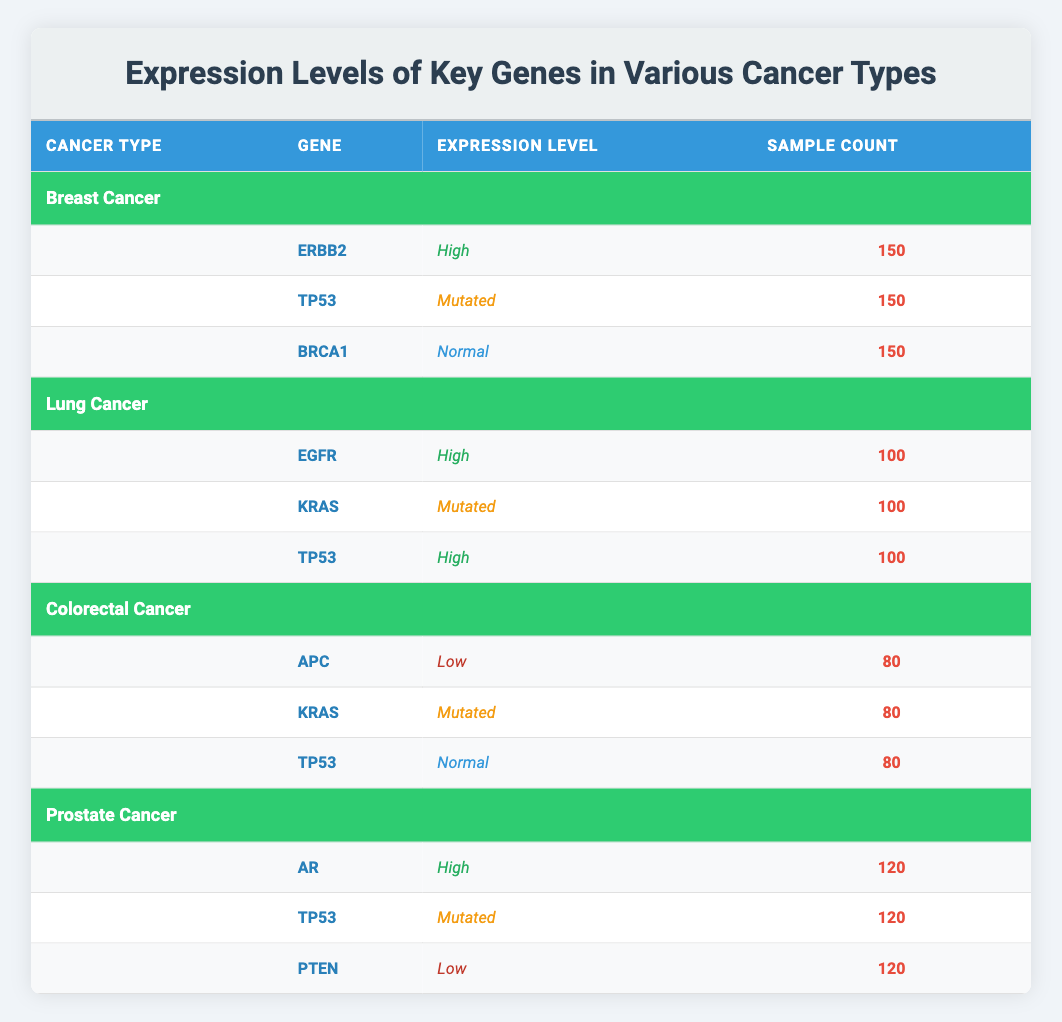What cancer type has the highest number of key genes expressed as "High"? From the table, both Breast Cancer and Lung Cancer have key genes expressed as "High." Breast Cancer has 1 (ERBB2), and Lung Cancer has 2 (EGFR and TP53). Thus, Lung Cancer has the highest number of key genes expressed as "High."
Answer: Lung Cancer Is the gene TP53 expressed as "Normal" in any type of cancer? From the table, TP53 is expressed as "Normal" in Colorectal Cancer only. For Breast and Lung cancers, it is "Mutated," and for Prostate Cancer, it is also "Mutated." Therefore, TP53 is "Normal" only in Colorectal Cancer.
Answer: Yes Which cancer type has the lowest sample count for a key gene? The sample count for key genes in Colorectal Cancer is 80 for all its genes (APC, KRAS, TP53). In comparison, other cancer types have at least one gene with a higher sample count (150 for Breast Cancer and 100 for Lung Cancer and Prostate Cancer). Thus, Colorectal Cancer has the lowest sample count for key genes.
Answer: Colorectal Cancer What is the total sample count for all key genes across all cancer types? By adding sample counts for each cancer type: Breast Cancer (150) + Lung Cancer (100) + Colorectal Cancer (80) + Prostate Cancer (120) = 150 + 100 + 80 + 120 = 450. Therefore, the total sample count is 450.
Answer: 450 Is there any cancer type where all its key genes are expressed as "Normal"? Analyzing the table shows that none of the cancer types has all key genes expressed as "Normal." For instance, Breast Cancer has one "High" and one "Mutated," and similar patterns are observed for other cancers. Hence, no cancer type exhibits all its genes as "Normal."
Answer: No Among the key genes in Prostate Cancer, which gene has the lowest expression level? In Prostate Cancer, the genes and their expression levels are as follows: AR (High), TP53 (Mutated), and PTEN (Low). PTEN is the only gene with the expression level marked as "Low." Hence, PTEN has the lowest expression level among Prostate Cancer key genes.
Answer: PTEN 